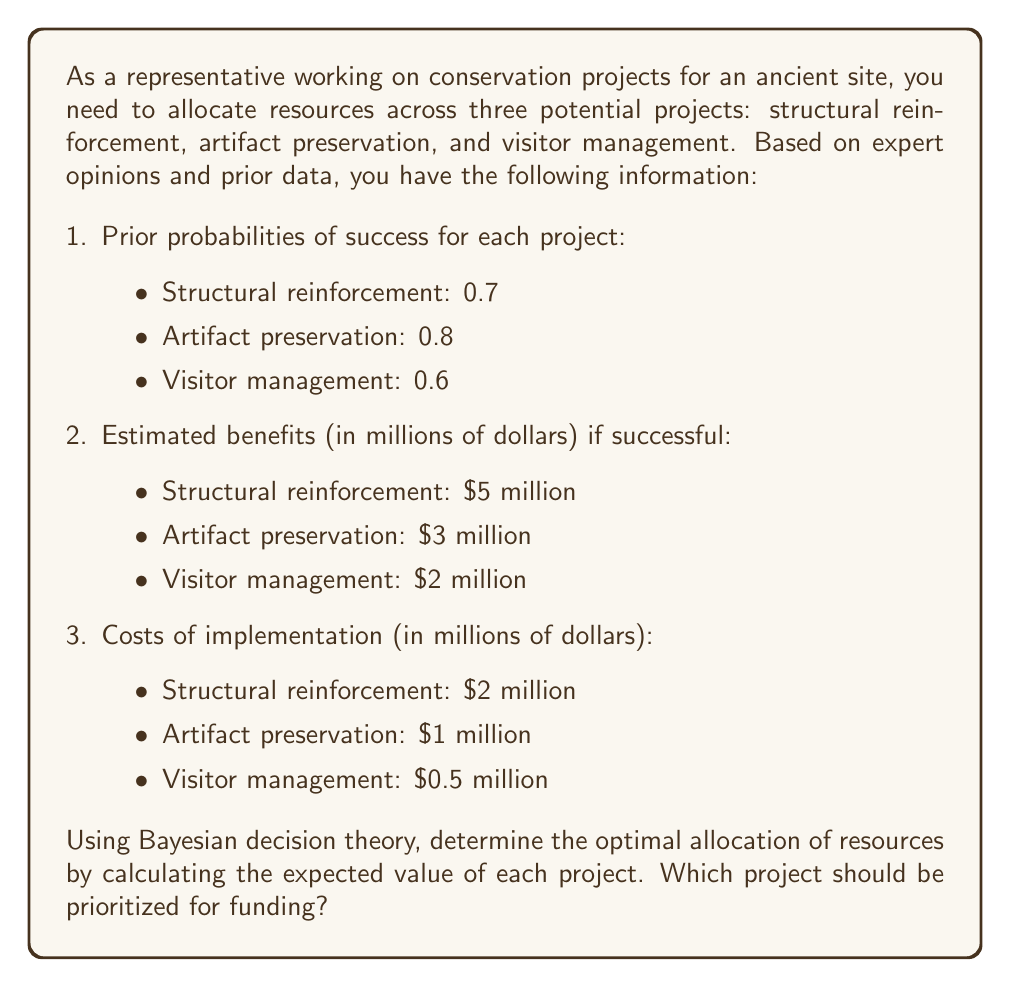Could you help me with this problem? To solve this problem using Bayesian decision theory, we need to calculate the expected value (EV) for each project. The expected value is the difference between the expected benefit and the cost of implementation.

For each project, we'll use the formula:

$$ EV = (P_{success} \times Benefit) - Cost $$

Where:
$P_{success}$ is the prior probability of success
$Benefit$ is the estimated benefit if successful
$Cost$ is the cost of implementation

Let's calculate the EV for each project:

1. Structural reinforcement:
   $$ EV_{structural} = (0.7 \times \$5 \text{ million}) - \$2 \text{ million} = \$3.5 \text{ million} - \$2 \text{ million} = \$1.5 \text{ million} $$

2. Artifact preservation:
   $$ EV_{artifacts} = (0.8 \times \$3 \text{ million}) - \$1 \text{ million} = \$2.4 \text{ million} - \$1 \text{ million} = \$1.4 \text{ million} $$

3. Visitor management:
   $$ EV_{visitors} = (0.6 \times \$2 \text{ million}) - \$0.5 \text{ million} = \$1.2 \text{ million} - \$0.5 \text{ million} = \$0.7 \text{ million} $$

Now, we can compare the expected values:

- Structural reinforcement: $1.5 million
- Artifact preservation: $1.4 million
- Visitor management: $0.7 million

The project with the highest expected value should be prioritized for funding, as it represents the best use of resources according to Bayesian decision theory.
Answer: The structural reinforcement project should be prioritized for funding, as it has the highest expected value of $1.5 million. 